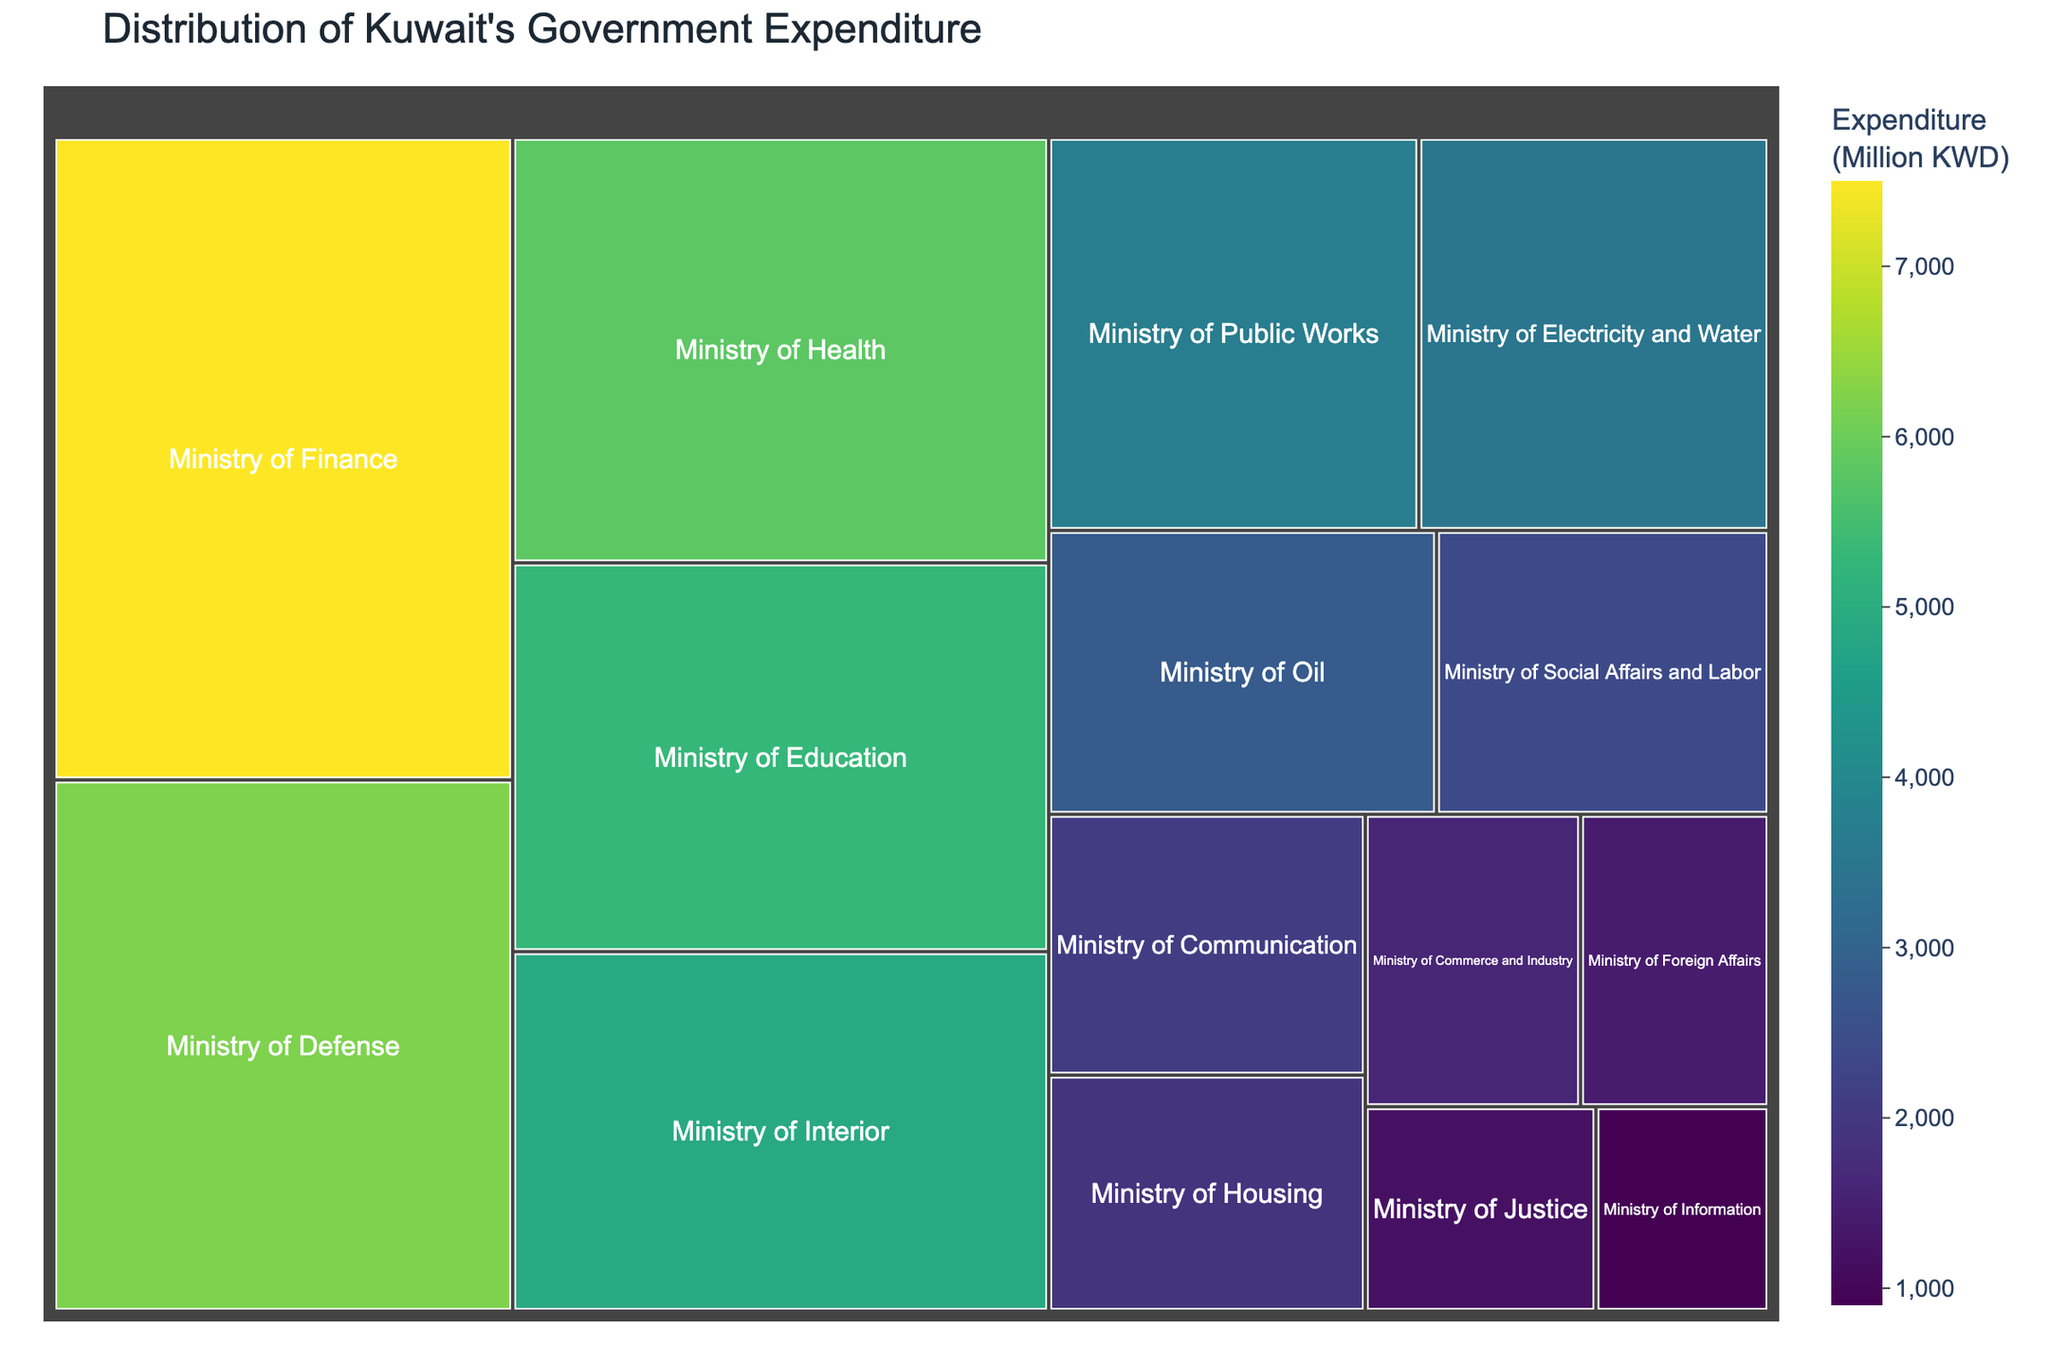What is the title of the treemap? The title is typically prominently displayed at the top of the figure and summarizes the main information being presented.
Answer: Distribution of Kuwait's Government Expenditure Which ministry has the highest expenditure? The largest rectangle in the treemap represents the ministry with the highest expenditure, which can be identified by looking at the labels.
Answer: Ministry of Finance Which ministry has the smallest expenditure? The smallest rectangle in the treemap signifies the ministry with the smallest expenditure. This can be identified by comparing the relative sizes of all rectangles.
Answer: Ministry of Information What is the total government expenditure represented in the treemap? Add the expenditure values for all ministries presented in the treemap: 7500 + 6200 + 5800 + 5300 + 4900 + 3700 + 3500 + 2800 + 2400 + 2100 + 1900 + 1600 + 1400 + 1200 + 900.
Answer: 52,200 What percentage of the total government expenditure does the Ministry of Education represent? (Ministry of Education expenditure / Total expenditure) * 100 = (5300 / 52200) * 100.
Answer: ~10.15% Which ministries have an expenditure that is greater than 4000? Compare each ministry's expenditure to the value of 4000. Ministries with higher expenditure are identified by rectangles larger than a certain threshold.
Answer: Ministry of Finance, Ministry of Defense, Ministry of Health, Ministry of Education, Ministry of Interior Is the expenditure on the Ministry of Health greater than that on the Ministry of Defense? Compare the expenditure values directly from the treemap: Ministry of Health (5800) vs. Ministry of Defense (6200).
Answer: No What is the difference in expenditure between the Ministry of Public Works and the Ministry of Communication? Subtract the expenditure of the Ministry of Communication (2100) from that of the Ministry of Public Works (3700).
Answer: 1600 Which ministries have expenditures between 2000 and 3000? Identify the rectangles representing expenditures within the range 2000-3000.
Answer: Ministry of Oil, Ministry of Social Affairs and Labor, Ministry of Communication What is the combined expenditure of the Ministry of Justice and Ministry of Commerce and Industry? Add the expenditure values of these two ministries: 1200 (Justice) + 1600 (Commerce and Industry).
Answer: 2800 